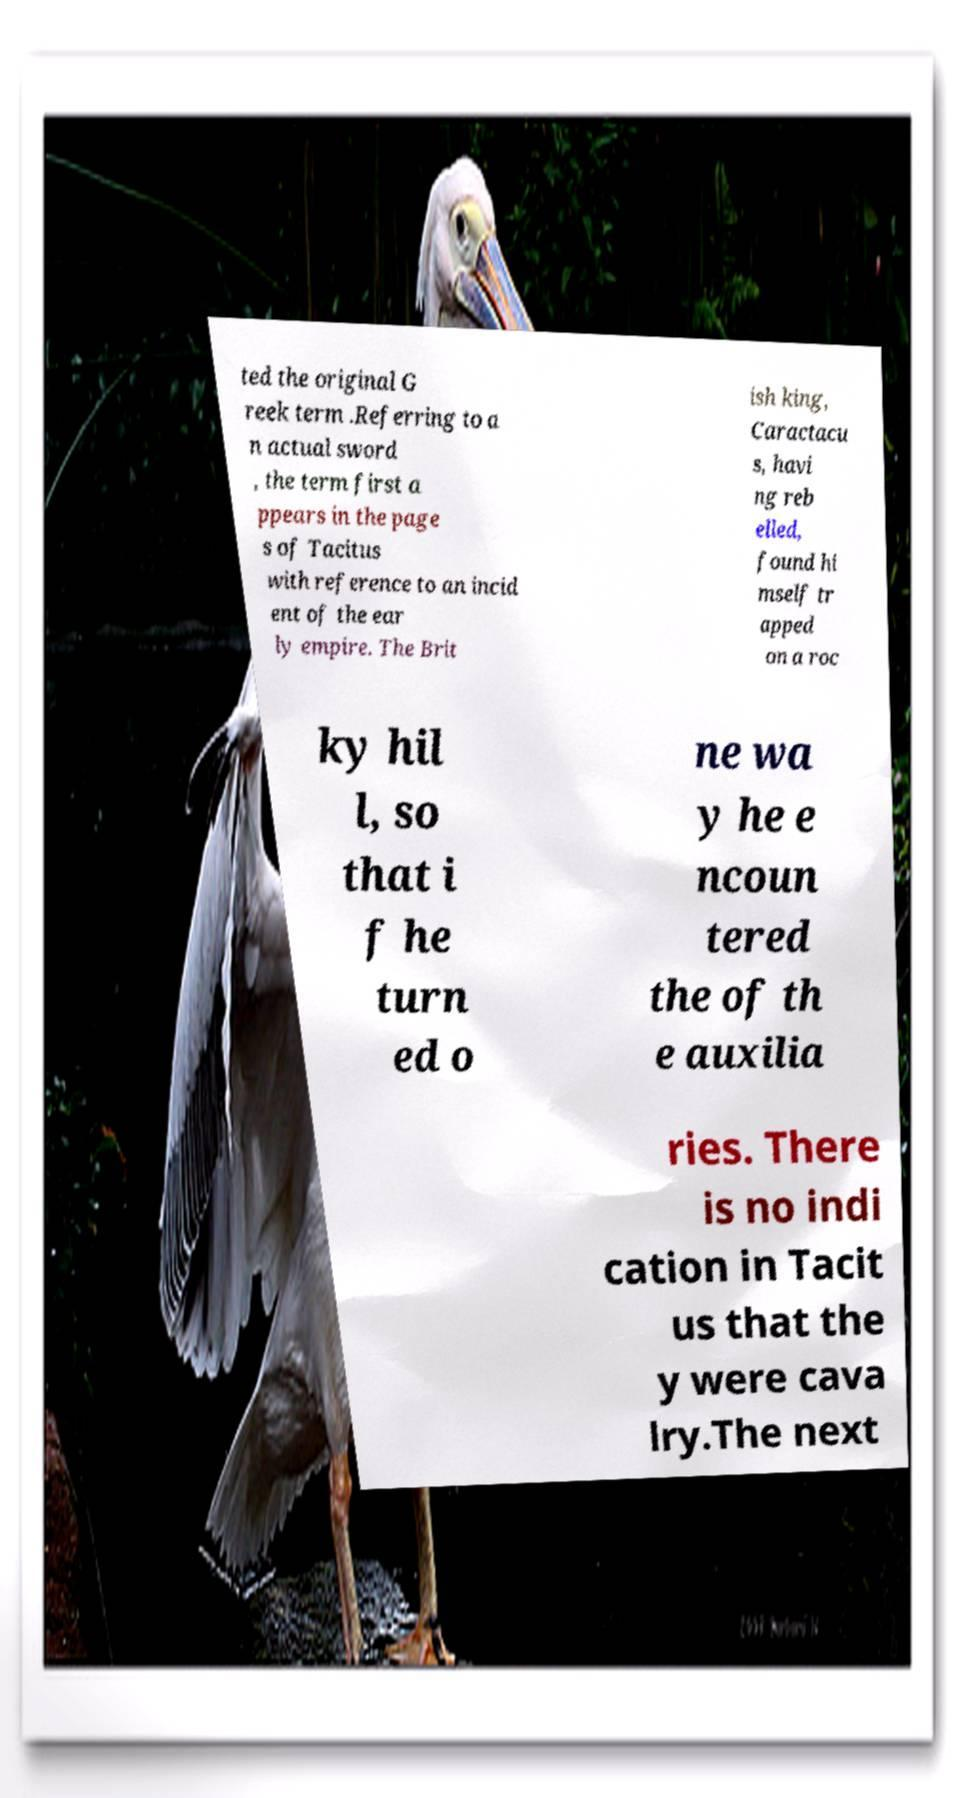Please identify and transcribe the text found in this image. ted the original G reek term .Referring to a n actual sword , the term first a ppears in the page s of Tacitus with reference to an incid ent of the ear ly empire. The Brit ish king, Caractacu s, havi ng reb elled, found hi mself tr apped on a roc ky hil l, so that i f he turn ed o ne wa y he e ncoun tered the of th e auxilia ries. There is no indi cation in Tacit us that the y were cava lry.The next 